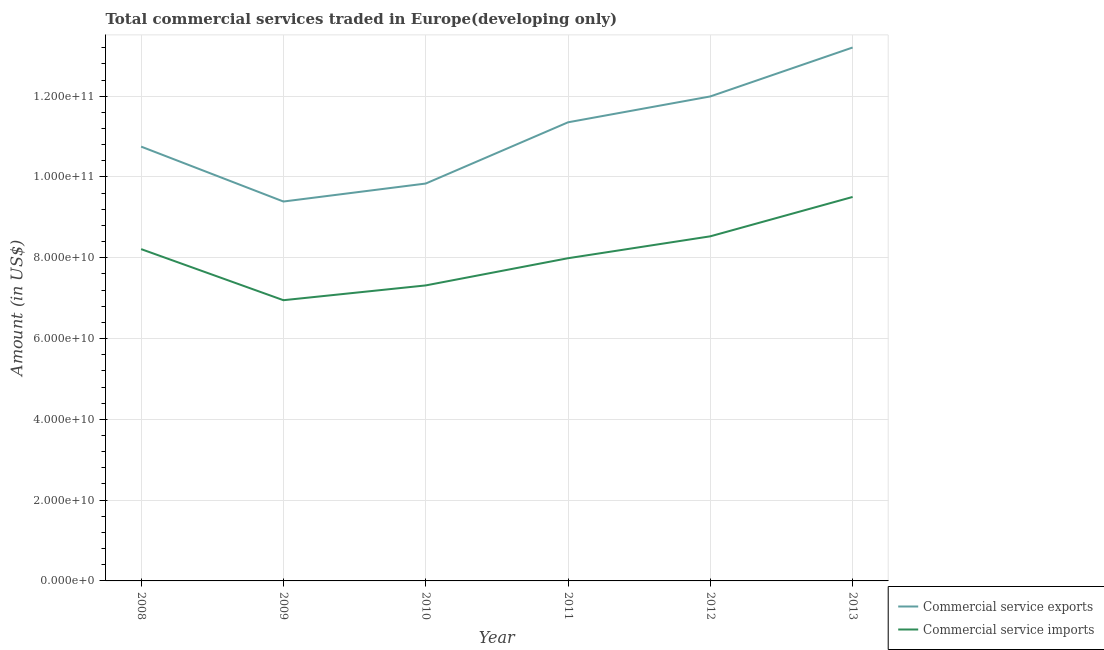How many different coloured lines are there?
Provide a succinct answer. 2. Does the line corresponding to amount of commercial service imports intersect with the line corresponding to amount of commercial service exports?
Keep it short and to the point. No. What is the amount of commercial service exports in 2011?
Provide a short and direct response. 1.14e+11. Across all years, what is the maximum amount of commercial service exports?
Ensure brevity in your answer.  1.32e+11. Across all years, what is the minimum amount of commercial service imports?
Your response must be concise. 6.95e+1. In which year was the amount of commercial service exports minimum?
Offer a terse response. 2009. What is the total amount of commercial service exports in the graph?
Offer a terse response. 6.65e+11. What is the difference between the amount of commercial service imports in 2012 and that in 2013?
Offer a very short reply. -9.74e+09. What is the difference between the amount of commercial service exports in 2010 and the amount of commercial service imports in 2011?
Ensure brevity in your answer.  1.85e+1. What is the average amount of commercial service imports per year?
Your answer should be very brief. 8.08e+1. In the year 2013, what is the difference between the amount of commercial service imports and amount of commercial service exports?
Provide a succinct answer. -3.70e+1. In how many years, is the amount of commercial service exports greater than 60000000000 US$?
Your answer should be compact. 6. What is the ratio of the amount of commercial service exports in 2008 to that in 2012?
Provide a short and direct response. 0.9. Is the amount of commercial service imports in 2011 less than that in 2013?
Your response must be concise. Yes. Is the difference between the amount of commercial service imports in 2009 and 2013 greater than the difference between the amount of commercial service exports in 2009 and 2013?
Offer a very short reply. Yes. What is the difference between the highest and the second highest amount of commercial service imports?
Provide a succinct answer. 9.74e+09. What is the difference between the highest and the lowest amount of commercial service imports?
Ensure brevity in your answer.  2.56e+1. Is the sum of the amount of commercial service exports in 2009 and 2013 greater than the maximum amount of commercial service imports across all years?
Ensure brevity in your answer.  Yes. Does the amount of commercial service exports monotonically increase over the years?
Ensure brevity in your answer.  No. Is the amount of commercial service imports strictly greater than the amount of commercial service exports over the years?
Ensure brevity in your answer.  No. How many years are there in the graph?
Ensure brevity in your answer.  6. What is the difference between two consecutive major ticks on the Y-axis?
Your answer should be very brief. 2.00e+1. Does the graph contain grids?
Ensure brevity in your answer.  Yes. What is the title of the graph?
Offer a terse response. Total commercial services traded in Europe(developing only). Does "ODA received" appear as one of the legend labels in the graph?
Make the answer very short. No. What is the label or title of the X-axis?
Make the answer very short. Year. What is the label or title of the Y-axis?
Your response must be concise. Amount (in US$). What is the Amount (in US$) of Commercial service exports in 2008?
Provide a succinct answer. 1.08e+11. What is the Amount (in US$) in Commercial service imports in 2008?
Provide a short and direct response. 8.21e+1. What is the Amount (in US$) of Commercial service exports in 2009?
Keep it short and to the point. 9.39e+1. What is the Amount (in US$) in Commercial service imports in 2009?
Offer a terse response. 6.95e+1. What is the Amount (in US$) of Commercial service exports in 2010?
Your response must be concise. 9.84e+1. What is the Amount (in US$) of Commercial service imports in 2010?
Provide a short and direct response. 7.32e+1. What is the Amount (in US$) in Commercial service exports in 2011?
Your answer should be very brief. 1.14e+11. What is the Amount (in US$) in Commercial service imports in 2011?
Give a very brief answer. 7.99e+1. What is the Amount (in US$) of Commercial service exports in 2012?
Make the answer very short. 1.20e+11. What is the Amount (in US$) in Commercial service imports in 2012?
Provide a succinct answer. 8.53e+1. What is the Amount (in US$) of Commercial service exports in 2013?
Offer a terse response. 1.32e+11. What is the Amount (in US$) of Commercial service imports in 2013?
Ensure brevity in your answer.  9.51e+1. Across all years, what is the maximum Amount (in US$) in Commercial service exports?
Give a very brief answer. 1.32e+11. Across all years, what is the maximum Amount (in US$) in Commercial service imports?
Provide a succinct answer. 9.51e+1. Across all years, what is the minimum Amount (in US$) in Commercial service exports?
Make the answer very short. 9.39e+1. Across all years, what is the minimum Amount (in US$) in Commercial service imports?
Provide a short and direct response. 6.95e+1. What is the total Amount (in US$) in Commercial service exports in the graph?
Provide a short and direct response. 6.65e+11. What is the total Amount (in US$) in Commercial service imports in the graph?
Keep it short and to the point. 4.85e+11. What is the difference between the Amount (in US$) of Commercial service exports in 2008 and that in 2009?
Ensure brevity in your answer.  1.36e+1. What is the difference between the Amount (in US$) of Commercial service imports in 2008 and that in 2009?
Offer a terse response. 1.26e+1. What is the difference between the Amount (in US$) of Commercial service exports in 2008 and that in 2010?
Your answer should be compact. 9.14e+09. What is the difference between the Amount (in US$) in Commercial service imports in 2008 and that in 2010?
Your response must be concise. 8.99e+09. What is the difference between the Amount (in US$) of Commercial service exports in 2008 and that in 2011?
Your response must be concise. -6.02e+09. What is the difference between the Amount (in US$) of Commercial service imports in 2008 and that in 2011?
Your answer should be very brief. 2.25e+09. What is the difference between the Amount (in US$) in Commercial service exports in 2008 and that in 2012?
Offer a very short reply. -1.24e+1. What is the difference between the Amount (in US$) in Commercial service imports in 2008 and that in 2012?
Your response must be concise. -3.17e+09. What is the difference between the Amount (in US$) in Commercial service exports in 2008 and that in 2013?
Keep it short and to the point. -2.45e+1. What is the difference between the Amount (in US$) of Commercial service imports in 2008 and that in 2013?
Make the answer very short. -1.29e+1. What is the difference between the Amount (in US$) in Commercial service exports in 2009 and that in 2010?
Make the answer very short. -4.45e+09. What is the difference between the Amount (in US$) of Commercial service imports in 2009 and that in 2010?
Your answer should be very brief. -3.66e+09. What is the difference between the Amount (in US$) in Commercial service exports in 2009 and that in 2011?
Ensure brevity in your answer.  -1.96e+1. What is the difference between the Amount (in US$) in Commercial service imports in 2009 and that in 2011?
Ensure brevity in your answer.  -1.04e+1. What is the difference between the Amount (in US$) of Commercial service exports in 2009 and that in 2012?
Give a very brief answer. -2.60e+1. What is the difference between the Amount (in US$) of Commercial service imports in 2009 and that in 2012?
Your answer should be very brief. -1.58e+1. What is the difference between the Amount (in US$) in Commercial service exports in 2009 and that in 2013?
Offer a terse response. -3.81e+1. What is the difference between the Amount (in US$) of Commercial service imports in 2009 and that in 2013?
Your answer should be very brief. -2.56e+1. What is the difference between the Amount (in US$) in Commercial service exports in 2010 and that in 2011?
Your answer should be very brief. -1.52e+1. What is the difference between the Amount (in US$) of Commercial service imports in 2010 and that in 2011?
Keep it short and to the point. -6.73e+09. What is the difference between the Amount (in US$) in Commercial service exports in 2010 and that in 2012?
Provide a short and direct response. -2.16e+1. What is the difference between the Amount (in US$) in Commercial service imports in 2010 and that in 2012?
Your answer should be compact. -1.22e+1. What is the difference between the Amount (in US$) of Commercial service exports in 2010 and that in 2013?
Offer a terse response. -3.37e+1. What is the difference between the Amount (in US$) in Commercial service imports in 2010 and that in 2013?
Your answer should be very brief. -2.19e+1. What is the difference between the Amount (in US$) in Commercial service exports in 2011 and that in 2012?
Provide a short and direct response. -6.41e+09. What is the difference between the Amount (in US$) in Commercial service imports in 2011 and that in 2012?
Your response must be concise. -5.42e+09. What is the difference between the Amount (in US$) in Commercial service exports in 2011 and that in 2013?
Ensure brevity in your answer.  -1.85e+1. What is the difference between the Amount (in US$) of Commercial service imports in 2011 and that in 2013?
Provide a succinct answer. -1.52e+1. What is the difference between the Amount (in US$) in Commercial service exports in 2012 and that in 2013?
Give a very brief answer. -1.21e+1. What is the difference between the Amount (in US$) in Commercial service imports in 2012 and that in 2013?
Offer a very short reply. -9.74e+09. What is the difference between the Amount (in US$) of Commercial service exports in 2008 and the Amount (in US$) of Commercial service imports in 2009?
Ensure brevity in your answer.  3.80e+1. What is the difference between the Amount (in US$) of Commercial service exports in 2008 and the Amount (in US$) of Commercial service imports in 2010?
Your response must be concise. 3.44e+1. What is the difference between the Amount (in US$) of Commercial service exports in 2008 and the Amount (in US$) of Commercial service imports in 2011?
Provide a succinct answer. 2.76e+1. What is the difference between the Amount (in US$) in Commercial service exports in 2008 and the Amount (in US$) in Commercial service imports in 2012?
Your answer should be compact. 2.22e+1. What is the difference between the Amount (in US$) of Commercial service exports in 2008 and the Amount (in US$) of Commercial service imports in 2013?
Your answer should be compact. 1.25e+1. What is the difference between the Amount (in US$) of Commercial service exports in 2009 and the Amount (in US$) of Commercial service imports in 2010?
Provide a succinct answer. 2.08e+1. What is the difference between the Amount (in US$) in Commercial service exports in 2009 and the Amount (in US$) in Commercial service imports in 2011?
Ensure brevity in your answer.  1.40e+1. What is the difference between the Amount (in US$) in Commercial service exports in 2009 and the Amount (in US$) in Commercial service imports in 2012?
Offer a terse response. 8.61e+09. What is the difference between the Amount (in US$) in Commercial service exports in 2009 and the Amount (in US$) in Commercial service imports in 2013?
Offer a terse response. -1.13e+09. What is the difference between the Amount (in US$) of Commercial service exports in 2010 and the Amount (in US$) of Commercial service imports in 2011?
Ensure brevity in your answer.  1.85e+1. What is the difference between the Amount (in US$) of Commercial service exports in 2010 and the Amount (in US$) of Commercial service imports in 2012?
Keep it short and to the point. 1.31e+1. What is the difference between the Amount (in US$) of Commercial service exports in 2010 and the Amount (in US$) of Commercial service imports in 2013?
Give a very brief answer. 3.32e+09. What is the difference between the Amount (in US$) of Commercial service exports in 2011 and the Amount (in US$) of Commercial service imports in 2012?
Make the answer very short. 2.82e+1. What is the difference between the Amount (in US$) in Commercial service exports in 2011 and the Amount (in US$) in Commercial service imports in 2013?
Your answer should be very brief. 1.85e+1. What is the difference between the Amount (in US$) in Commercial service exports in 2012 and the Amount (in US$) in Commercial service imports in 2013?
Keep it short and to the point. 2.49e+1. What is the average Amount (in US$) of Commercial service exports per year?
Ensure brevity in your answer.  1.11e+11. What is the average Amount (in US$) in Commercial service imports per year?
Make the answer very short. 8.08e+1. In the year 2008, what is the difference between the Amount (in US$) in Commercial service exports and Amount (in US$) in Commercial service imports?
Your answer should be compact. 2.54e+1. In the year 2009, what is the difference between the Amount (in US$) in Commercial service exports and Amount (in US$) in Commercial service imports?
Make the answer very short. 2.44e+1. In the year 2010, what is the difference between the Amount (in US$) in Commercial service exports and Amount (in US$) in Commercial service imports?
Ensure brevity in your answer.  2.52e+1. In the year 2011, what is the difference between the Amount (in US$) in Commercial service exports and Amount (in US$) in Commercial service imports?
Provide a succinct answer. 3.36e+1. In the year 2012, what is the difference between the Amount (in US$) in Commercial service exports and Amount (in US$) in Commercial service imports?
Your answer should be compact. 3.46e+1. In the year 2013, what is the difference between the Amount (in US$) of Commercial service exports and Amount (in US$) of Commercial service imports?
Give a very brief answer. 3.70e+1. What is the ratio of the Amount (in US$) in Commercial service exports in 2008 to that in 2009?
Provide a succinct answer. 1.14. What is the ratio of the Amount (in US$) in Commercial service imports in 2008 to that in 2009?
Provide a short and direct response. 1.18. What is the ratio of the Amount (in US$) of Commercial service exports in 2008 to that in 2010?
Give a very brief answer. 1.09. What is the ratio of the Amount (in US$) in Commercial service imports in 2008 to that in 2010?
Make the answer very short. 1.12. What is the ratio of the Amount (in US$) of Commercial service exports in 2008 to that in 2011?
Offer a very short reply. 0.95. What is the ratio of the Amount (in US$) in Commercial service imports in 2008 to that in 2011?
Make the answer very short. 1.03. What is the ratio of the Amount (in US$) of Commercial service exports in 2008 to that in 2012?
Your answer should be very brief. 0.9. What is the ratio of the Amount (in US$) in Commercial service imports in 2008 to that in 2012?
Your answer should be compact. 0.96. What is the ratio of the Amount (in US$) of Commercial service exports in 2008 to that in 2013?
Your response must be concise. 0.81. What is the ratio of the Amount (in US$) of Commercial service imports in 2008 to that in 2013?
Provide a succinct answer. 0.86. What is the ratio of the Amount (in US$) of Commercial service exports in 2009 to that in 2010?
Give a very brief answer. 0.95. What is the ratio of the Amount (in US$) in Commercial service imports in 2009 to that in 2010?
Provide a short and direct response. 0.95. What is the ratio of the Amount (in US$) of Commercial service exports in 2009 to that in 2011?
Offer a very short reply. 0.83. What is the ratio of the Amount (in US$) of Commercial service imports in 2009 to that in 2011?
Your answer should be very brief. 0.87. What is the ratio of the Amount (in US$) of Commercial service exports in 2009 to that in 2012?
Keep it short and to the point. 0.78. What is the ratio of the Amount (in US$) in Commercial service imports in 2009 to that in 2012?
Make the answer very short. 0.81. What is the ratio of the Amount (in US$) in Commercial service exports in 2009 to that in 2013?
Provide a succinct answer. 0.71. What is the ratio of the Amount (in US$) of Commercial service imports in 2009 to that in 2013?
Give a very brief answer. 0.73. What is the ratio of the Amount (in US$) of Commercial service exports in 2010 to that in 2011?
Your answer should be very brief. 0.87. What is the ratio of the Amount (in US$) of Commercial service imports in 2010 to that in 2011?
Offer a very short reply. 0.92. What is the ratio of the Amount (in US$) in Commercial service exports in 2010 to that in 2012?
Your response must be concise. 0.82. What is the ratio of the Amount (in US$) of Commercial service imports in 2010 to that in 2012?
Your answer should be very brief. 0.86. What is the ratio of the Amount (in US$) in Commercial service exports in 2010 to that in 2013?
Ensure brevity in your answer.  0.74. What is the ratio of the Amount (in US$) in Commercial service imports in 2010 to that in 2013?
Offer a terse response. 0.77. What is the ratio of the Amount (in US$) in Commercial service exports in 2011 to that in 2012?
Your response must be concise. 0.95. What is the ratio of the Amount (in US$) of Commercial service imports in 2011 to that in 2012?
Your response must be concise. 0.94. What is the ratio of the Amount (in US$) of Commercial service exports in 2011 to that in 2013?
Offer a terse response. 0.86. What is the ratio of the Amount (in US$) in Commercial service imports in 2011 to that in 2013?
Your answer should be compact. 0.84. What is the ratio of the Amount (in US$) in Commercial service exports in 2012 to that in 2013?
Keep it short and to the point. 0.91. What is the ratio of the Amount (in US$) in Commercial service imports in 2012 to that in 2013?
Offer a terse response. 0.9. What is the difference between the highest and the second highest Amount (in US$) of Commercial service exports?
Ensure brevity in your answer.  1.21e+1. What is the difference between the highest and the second highest Amount (in US$) in Commercial service imports?
Your answer should be compact. 9.74e+09. What is the difference between the highest and the lowest Amount (in US$) of Commercial service exports?
Your response must be concise. 3.81e+1. What is the difference between the highest and the lowest Amount (in US$) in Commercial service imports?
Ensure brevity in your answer.  2.56e+1. 